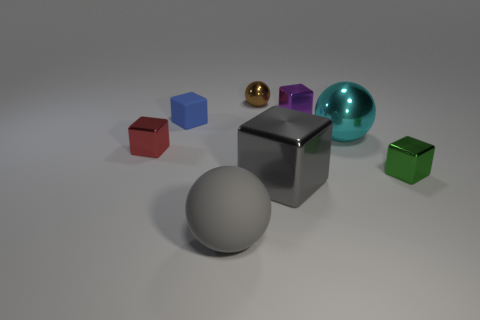Subtract all blue blocks. How many blocks are left? 4 Subtract all green cubes. How many cubes are left? 4 Subtract all gray blocks. Subtract all brown cylinders. How many blocks are left? 4 Add 1 yellow metal cylinders. How many objects exist? 9 Subtract all cubes. How many objects are left? 3 Subtract 0 gray cylinders. How many objects are left? 8 Subtract all small blue cubes. Subtract all small brown things. How many objects are left? 6 Add 5 tiny blue rubber blocks. How many tiny blue rubber blocks are left? 6 Add 3 small purple matte spheres. How many small purple matte spheres exist? 3 